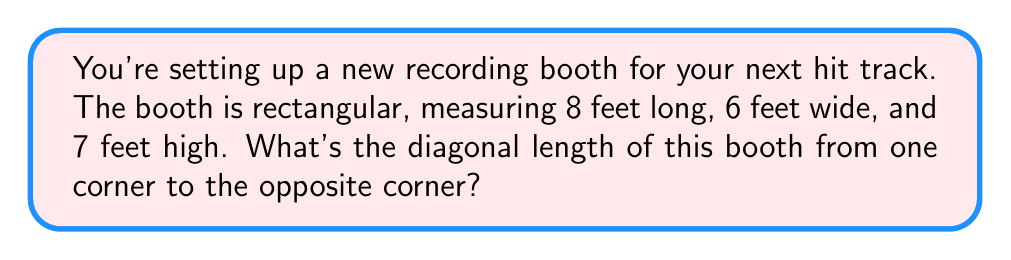Could you help me with this problem? Let's approach this step-by-step using the three-dimensional Pythagorean theorem:

1) In a rectangular prism, the diagonal can be calculated using the formula:
   $$d = \sqrt{l^2 + w^2 + h^2}$$
   where $d$ is the diagonal, $l$ is length, $w$ is width, and $h$ is height.

2) We're given:
   - Length ($l$) = 8 feet
   - Width ($w$) = 6 feet
   - Height ($h$) = 7 feet

3) Let's substitute these values into our formula:
   $$d = \sqrt{8^2 + 6^2 + 7^2}$$

4) Now, let's calculate:
   $$d = \sqrt{64 + 36 + 49}$$

5) Simplify inside the square root:
   $$d = \sqrt{149}$$

6) Calculate the square root:
   $$d \approx 12.21 \text{ feet}$$

[asy]
import three;

size(200);
currentprojection=perspective(6,3,2);

draw((0,0,0)--(8,0,0)--(8,6,0)--(0,6,0)--cycle);
draw((0,0,7)--(8,0,7)--(8,6,7)--(0,6,7)--cycle);
draw((0,0,0)--(0,0,7));
draw((8,0,0)--(8,0,7));
draw((8,6,0)--(8,6,7));
draw((0,6,0)--(0,6,7));

draw((0,0,0)--(8,6,7),red);

label("8'",(4,0,0),S);
label("6'",(8,3,0),E);
label("7'",(8,6,3.5),NE);
label("d",(4,3,3.5),NW);
[/asy]
Answer: $12.21 \text{ feet}$ 